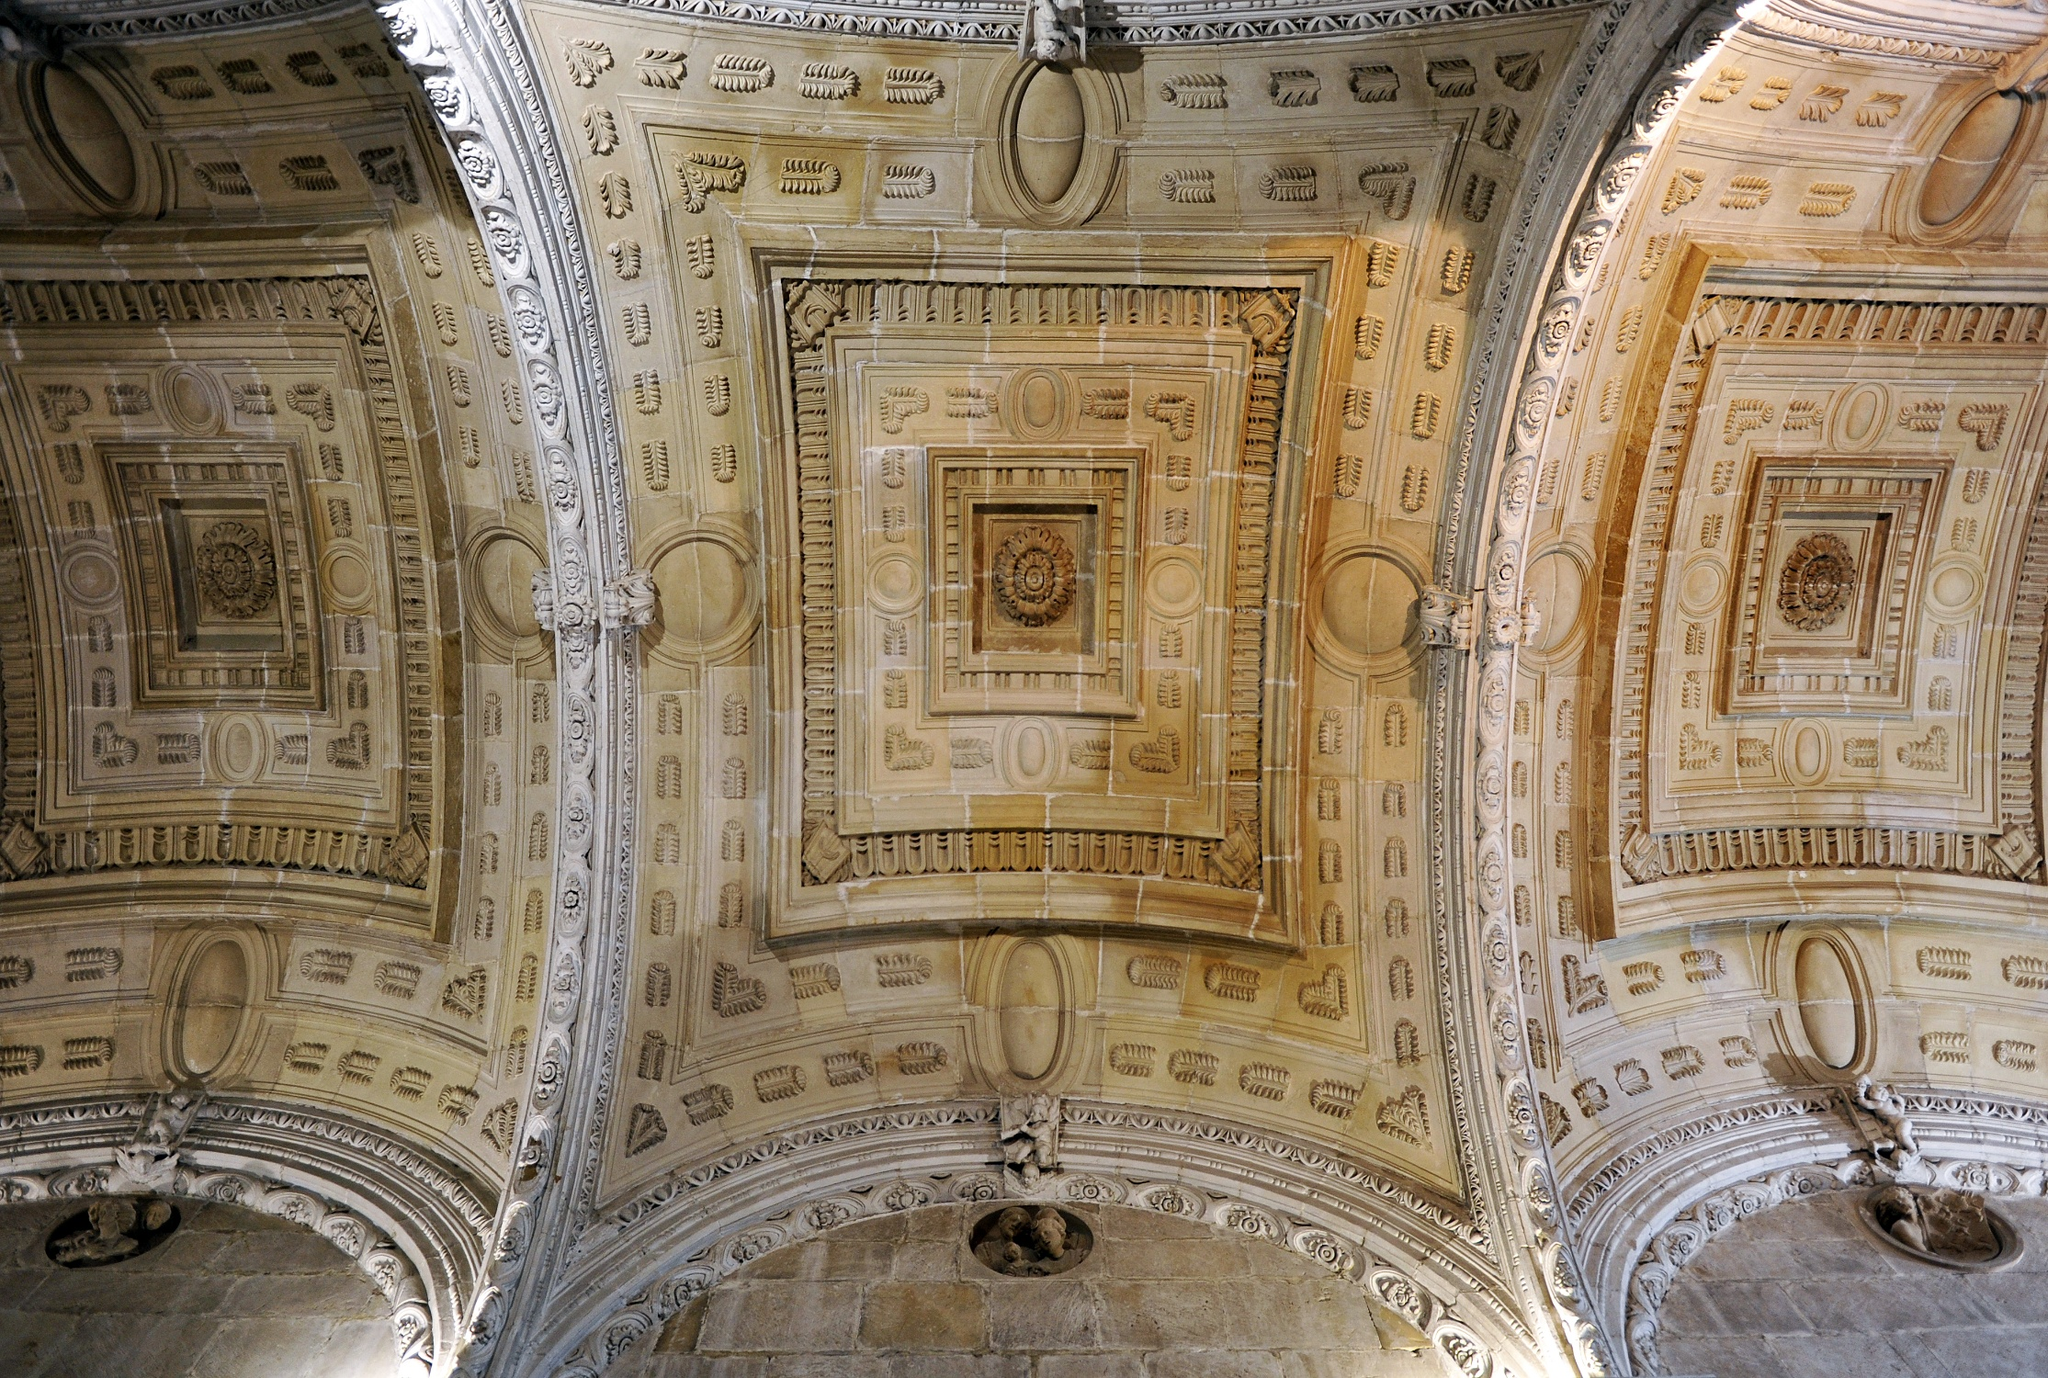Tell a story about the craftsmen who built this ceiling. In the heart of the ancient city, a group of master craftsmen gathered to build a ceiling that would stand the test of time. These artisans, descendants of generations of skilled workers, brought with them techniques passed down through the ages. They meticulously carved and sculpted each piece, infusing their work with a sense of pride and dedication. The leader of the group, a seasoned craftsman named Alejandro, oversaw the project with an eagle eye, ensuring that every detail met their exacting standards. For months, they toiled under the harsh light of day and the soft glow of night lamps, their hands guided by the wisdom embedded in their veins. As the ceiling took shape, it became a canvas of their collective memory, a testament to their heritage and a gift to future generations. Upon completion, the ceiling bore the marks of their labor and artistry, standing as a symbol of the artistry and dedication that defined their lives. What kind of events might have taken place under this ceiling in its prime? In its prime, this ceiling likely witnessed numerous grand events and ceremonies. It could have been the site of extravagant banquets hosted by nobility, where lords and ladies adorned in luxurious clothing gathered to partake in feasts and revelry. The acoustics of the hall would have echoed with the sounds of music, laughter, and conversations. It is also plausible that significant political meetings and declarations would have been made under this ceiling, with decisions that shaped the course of history. Additionally, religious ceremonies, with the chanting of hymns and prayers rising up to the decorated arches, may have taken place here, evoking a sense of reverence and divine presence. 